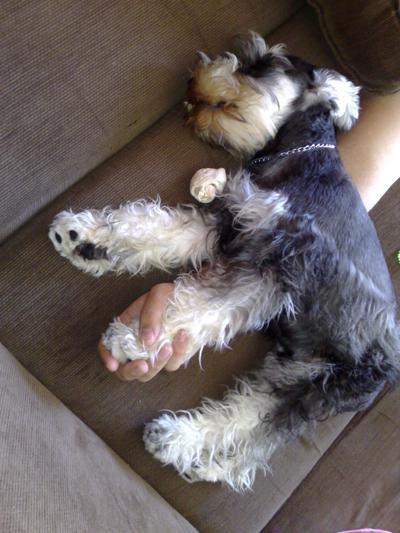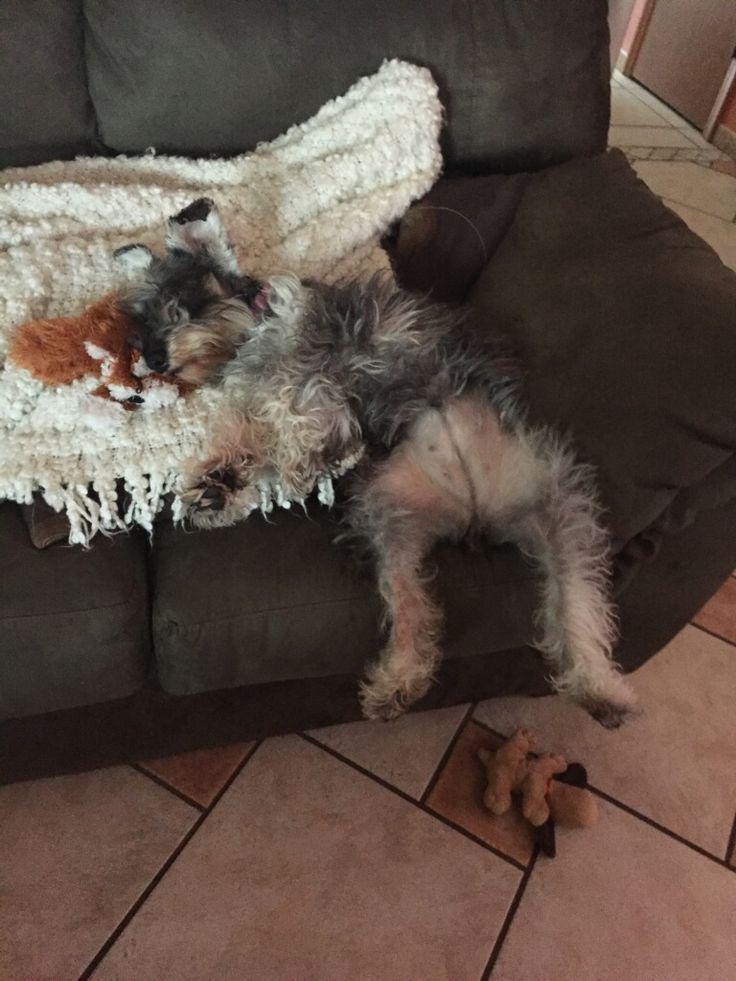The first image is the image on the left, the second image is the image on the right. For the images shown, is this caption "At least one dog is laying on a couch." true? Answer yes or no. Yes. The first image is the image on the left, the second image is the image on the right. Given the left and right images, does the statement "At least one dog is looking straight ahead." hold true? Answer yes or no. No. 